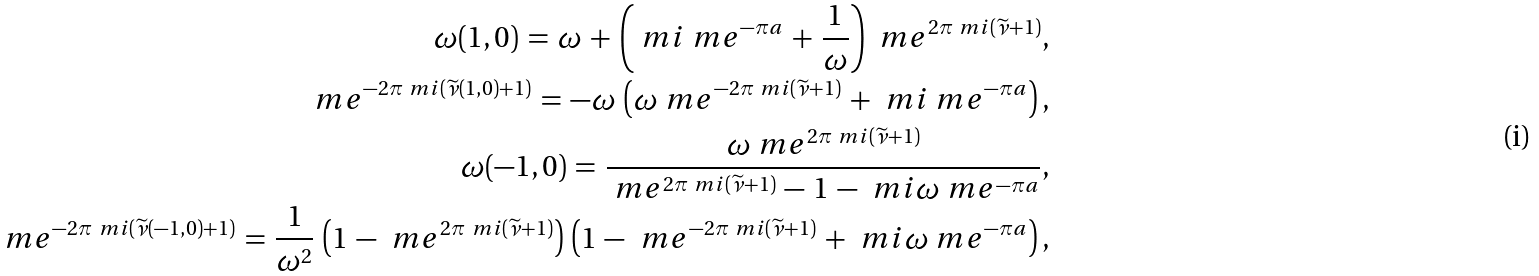<formula> <loc_0><loc_0><loc_500><loc_500>\omega ( 1 , 0 ) \, = \, \omega \, + \, \left ( \ m i \ m e ^ { - \pi a } \, + \, \frac { 1 } { \omega } \right ) \, \ m e ^ { 2 \pi \ m i ( \widetilde { \nu } + 1 ) } , \\ \ m e ^ { - 2 \pi \ m i ( \widetilde { \nu } ( 1 , 0 ) + 1 ) } \, = \, - \omega \, \left ( \omega \ m e ^ { - 2 \pi \ m i ( \widetilde { \nu } + 1 ) } \, + \, \ m i \ m e ^ { - \pi a } \right ) , \\ \omega ( - 1 , 0 ) \, = \, \frac { \omega \ m e ^ { 2 \pi \ m i ( \widetilde { \nu } + 1 ) } } { \ m e ^ { 2 \pi \ m i ( \widetilde { \nu } + 1 ) } \, - \, 1 \, - \, \ m i \omega \ m e ^ { - \pi a } } , \\ \ m e ^ { - 2 \pi \ m i ( \widetilde { \nu } ( - 1 , 0 ) + 1 ) } \, = \, \frac { 1 } { \omega ^ { 2 } } \, \left ( 1 \, - \, \ m e ^ { 2 \pi \ m i ( \widetilde { \nu } + 1 ) } \right ) \, \left ( 1 \, - \, \ m e ^ { - 2 \pi \ m i ( \widetilde { \nu } + 1 ) } \, + \, \ m i \omega \ m e ^ { - \pi a } \right ) ,</formula> 